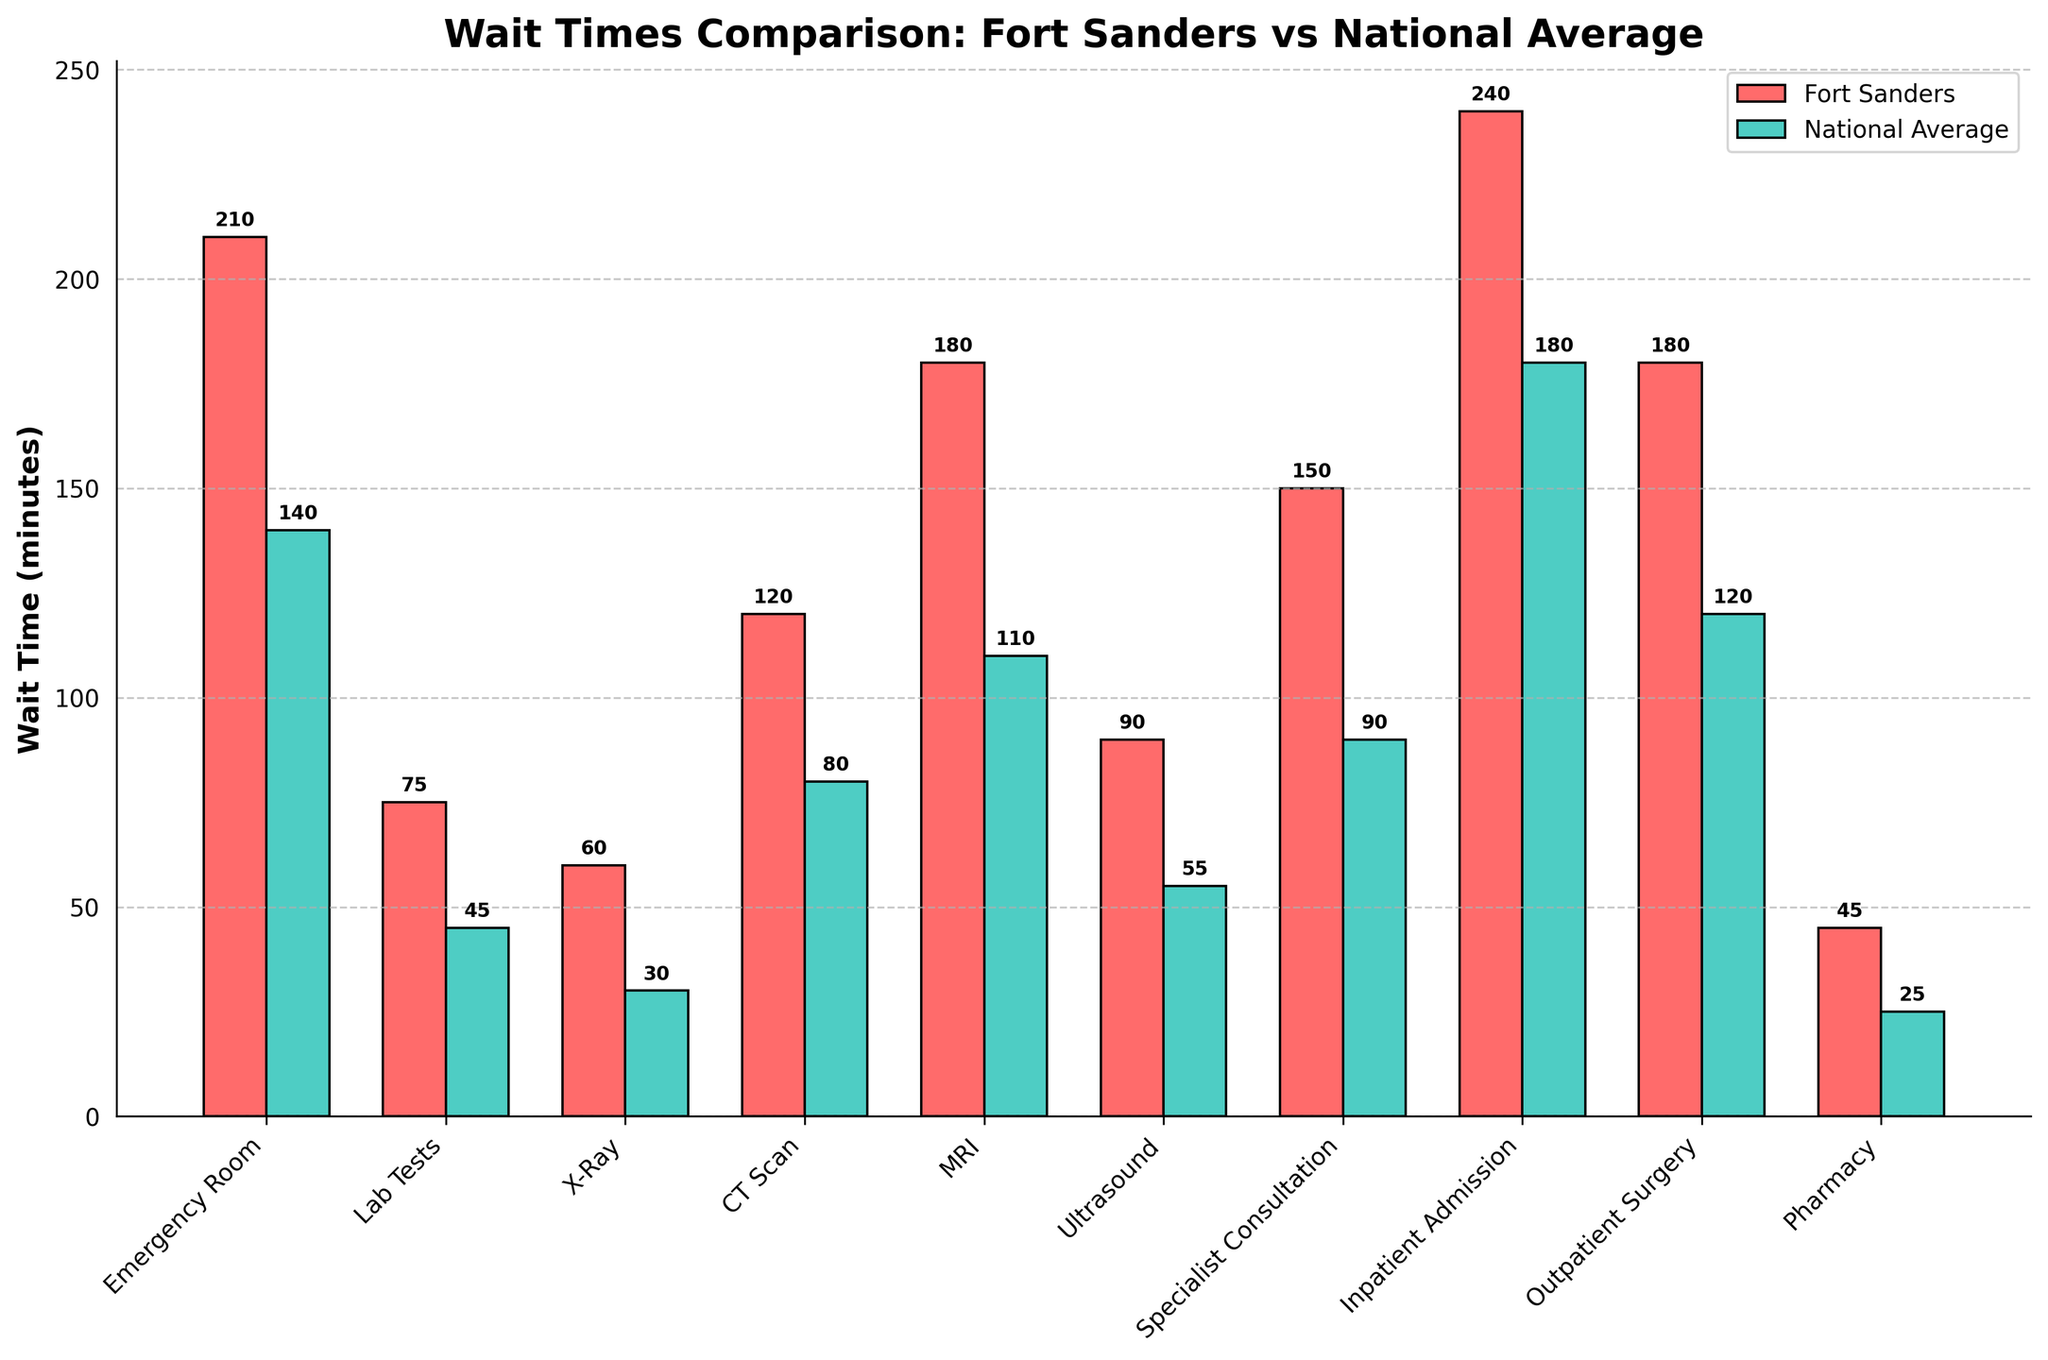Which service has the longest wait time at Fort Sanders Regional Medical Center? Look for the tallest red bar representing Fort Sanders wait times and identify the corresponding service.
Answer: Inpatient Admission How much longer is the MRI wait time at Fort Sanders compared to the national average? Subtract the national average wait time for MRI (110 minutes) from the Fort Sanders wait time for MRI (180 minutes): 180 - 110.
Answer: 70 minutes What is the difference between the Fort Sanders and the national average wait times for the Emergency Room? Subtract the national average wait time (140 minutes) from the Fort Sanders wait time (210 minutes): 210 - 140.
Answer: 70 minutes Which service has the smallest difference in wait times between Fort Sanders and the national average? Compare the differences for all services by subtracting national average times from Fort Sanders times and identify the smallest difference. Pharmacy has the smallest difference: 45 - 25.
Answer: Pharmacy For which service is the national average wait time less than half the wait time at Fort Sanders? Determine if national average wait times are less than half the Fort Sanders wait times. Emergency Room: 140 < 210/2, Lab Tests: 45 < 75/2, X-Ray: 30 < 60/2, etc.
Answer: None Which wait time is longer at Fort Sanders, Ultrasound or X-Ray, and by how much? Compare the wait times by looking at the height of the red bars for Ultrasound (90 minutes) and X-Ray (60 minutes): 90 - 60.
Answer: Ultrasound, 30 minutes By how many minutes does the Specialist Consultation wait time at Fort Sanders exceed the national average? Subtract the national average wait time for Specialist Consultation (90 minutes) from Fort Sanders' wait time (150 minutes): 150 - 90.
Answer: 60 minutes Is the wait time for Outpatient Surgery at Fort Sanders more than double the national average wait time for any service? Check if the wait time for Outpatient Surgery (180 minutes) is more than double any national average wait time. Outpatient Surgery vs others: 180 > 2 * 25 (Pharmacy) etc.
Answer: Yes What is the total wait time at Fort Sanders for services that have a wait time more than 100 minutes? Add the wait times for services with more than 100 minutes at Fort Sanders: Emergency Room (210), CT Scan (120), MRI (180), Specialist Consultation (150), Inpatient Admission (240), Outpatient Surgery (180). 210 + 120 + 180 + 150 + 240 + 180.
Answer: 1080 minutes Which service has the greatest wait time disparity between Fort Sanders and the national average, and what is the difference? Identify the largest difference between Fort Sanders and national average wait times by computing the difference for each service. Inpatient Admission has the greatest disparity: 240 - 180.
Answer: Inpatient Admission, 60 minutes 